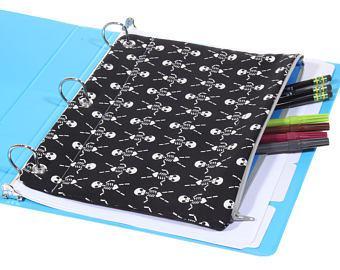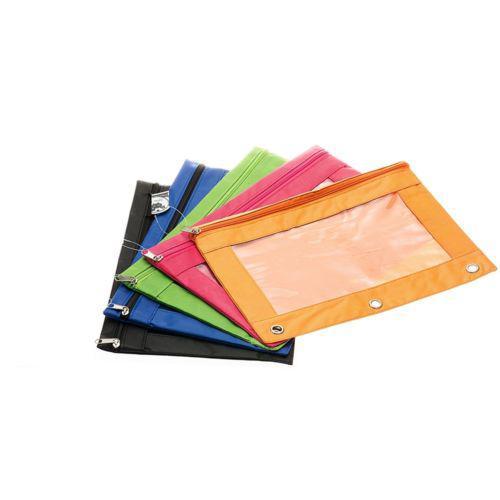The first image is the image on the left, the second image is the image on the right. For the images shown, is this caption "An image shows an open three-ring binder containing a pencil case, and the other image includes a pencil case that is not in a binder." true? Answer yes or no. Yes. The first image is the image on the left, the second image is the image on the right. Given the left and right images, does the statement "writing utensils are sticking out of every single pencil case." hold true? Answer yes or no. No. 